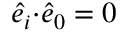Convert formula to latex. <formula><loc_0><loc_0><loc_500><loc_500>\hat { e } _ { i } { \cdot } \hat { e } _ { 0 } = 0</formula> 